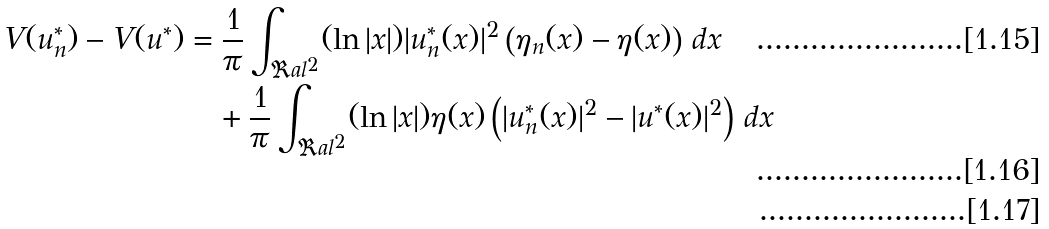<formula> <loc_0><loc_0><loc_500><loc_500>V ( u ^ { * } _ { n } ) - V ( u ^ { * } ) & = \frac { 1 } { \pi } \int _ { \Re a l ^ { 2 } } ( \ln | x | ) | u ^ { * } _ { n } ( x ) | ^ { 2 } \left ( \eta _ { n } ( x ) - \eta ( x ) \right ) \, d x \\ & \quad + \frac { 1 } { \pi } \int _ { \Re a l ^ { 2 } } ( \ln | x | ) \eta ( x ) \left ( | u ^ { * } _ { n } ( x ) | ^ { 2 } - | u ^ { * } ( x ) | ^ { 2 } \right ) \, d x \\</formula> 